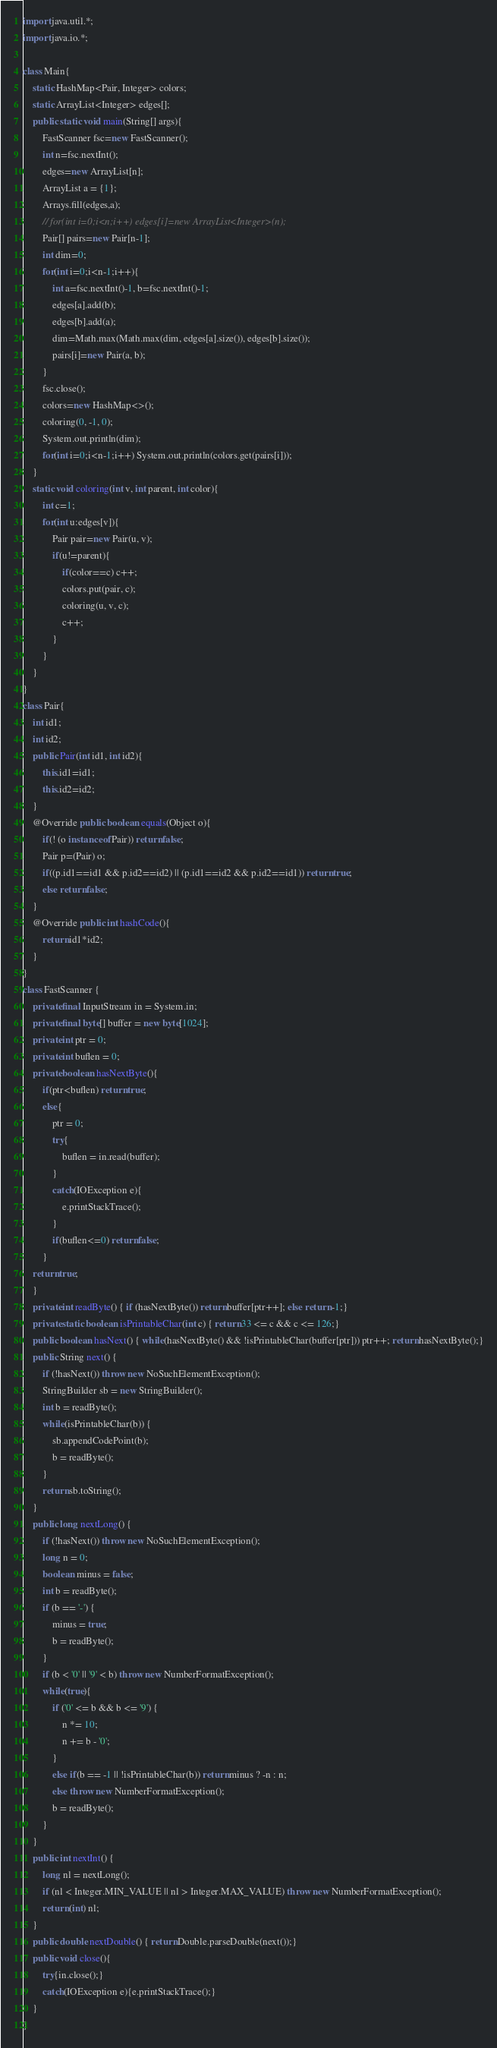<code> <loc_0><loc_0><loc_500><loc_500><_Java_>import java.util.*;
import java.io.*;

class Main{
    static HashMap<Pair, Integer> colors;
    static ArrayList<Integer> edges[];
    public static void main(String[] args){
        FastScanner fsc=new FastScanner();
        int n=fsc.nextInt();
        edges=new ArrayList[n];
        ArrayList a = {1};
        Arrays.fill(edges,a);
        // for(int i=0;i<n;i++) edges[i]=new ArrayList<Integer>(n);
        Pair[] pairs=new Pair[n-1];
        int dim=0;
        for(int i=0;i<n-1;i++){
            int a=fsc.nextInt()-1, b=fsc.nextInt()-1;
            edges[a].add(b);
            edges[b].add(a);
            dim=Math.max(Math.max(dim, edges[a].size()), edges[b].size());
            pairs[i]=new Pair(a, b);
        }
        fsc.close();
        colors=new HashMap<>();
        coloring(0, -1, 0);
        System.out.println(dim);
        for(int i=0;i<n-1;i++) System.out.println(colors.get(pairs[i]));
    }
    static void coloring(int v, int parent, int color){
        int c=1;
        for(int u:edges[v]){
            Pair pair=new Pair(u, v);
            if(u!=parent){
                if(color==c) c++;
                colors.put(pair, c);
                coloring(u, v, c);
                c++;
            }
        }
    }
}
class Pair{
    int id1;
    int id2;
    public Pair(int id1, int id2){
        this.id1=id1;
        this.id2=id2;
    }
    @Override public boolean equals(Object o){
        if(! (o instanceof Pair)) return false;
        Pair p=(Pair) o;
        if((p.id1==id1 && p.id2==id2) || (p.id1==id2 && p.id2==id1)) return true;
        else return false;
    }
    @Override public int hashCode(){
        return id1*id2;
    }
}
class FastScanner {
    private final InputStream in = System.in;
    private final byte[] buffer = new byte[1024];
    private int ptr = 0;
    private int buflen = 0;
    private boolean hasNextByte(){
        if(ptr<buflen) return true;
        else{
            ptr = 0;
            try{
                buflen = in.read(buffer);
            }
            catch(IOException e){
                e.printStackTrace();
            }
            if(buflen<=0) return false;
        }
    return true;
    }
    private int readByte() { if (hasNextByte()) return buffer[ptr++]; else return -1;}
    private static boolean isPrintableChar(int c) { return 33 <= c && c <= 126;}
    public boolean hasNext() { while(hasNextByte() && !isPrintableChar(buffer[ptr])) ptr++; return hasNextByte();}
    public String next() {
        if (!hasNext()) throw new NoSuchElementException();
        StringBuilder sb = new StringBuilder();
        int b = readByte();
        while(isPrintableChar(b)) {
            sb.appendCodePoint(b);
            b = readByte();
        }
        return sb.toString();
    }
    public long nextLong() {
        if (!hasNext()) throw new NoSuchElementException();
        long n = 0;
        boolean minus = false;
        int b = readByte();
        if (b == '-') {
            minus = true;
            b = readByte();
        }
        if (b < '0' || '9' < b) throw new NumberFormatException();
        while(true){
            if ('0' <= b && b <= '9') {
                n *= 10;
                n += b - '0';
            }
            else if(b == -1 || !isPrintableChar(b)) return minus ? -n : n;
            else throw new NumberFormatException();
            b = readByte();
        }
    }
    public int nextInt() {
        long nl = nextLong();
        if (nl < Integer.MIN_VALUE || nl > Integer.MAX_VALUE) throw new NumberFormatException();
        return (int) nl;
    }
    public double nextDouble() { return Double.parseDouble(next());}
    public void close(){
        try{in.close();}
        catch(IOException e){e.printStackTrace();}
    }
}
</code> 